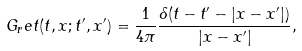<formula> <loc_0><loc_0><loc_500><loc_500>G _ { r } e t ( t , x ; t ^ { \prime } , x ^ { \prime } ) = \frac { 1 } { 4 \pi } \frac { \delta ( t - t ^ { \prime } - | x - x ^ { \prime } | ) } { | x - x ^ { \prime } | } ,</formula> 